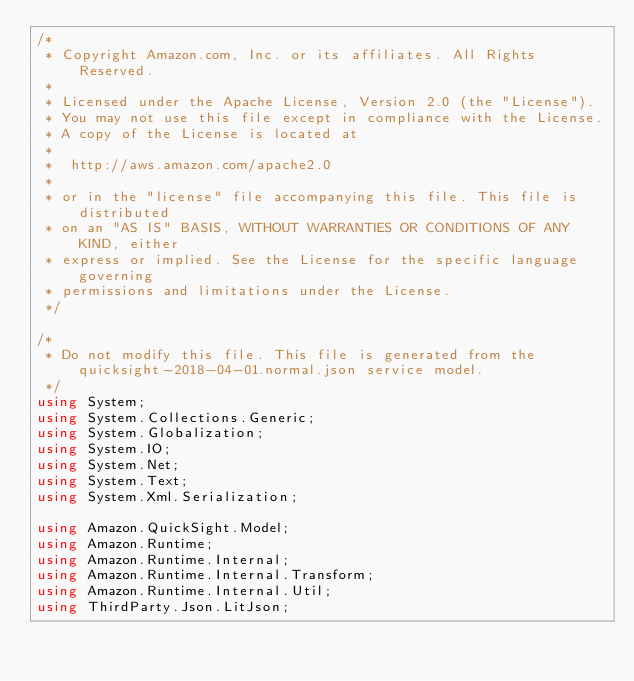Convert code to text. <code><loc_0><loc_0><loc_500><loc_500><_C#_>/*
 * Copyright Amazon.com, Inc. or its affiliates. All Rights Reserved.
 * 
 * Licensed under the Apache License, Version 2.0 (the "License").
 * You may not use this file except in compliance with the License.
 * A copy of the License is located at
 * 
 *  http://aws.amazon.com/apache2.0
 * 
 * or in the "license" file accompanying this file. This file is distributed
 * on an "AS IS" BASIS, WITHOUT WARRANTIES OR CONDITIONS OF ANY KIND, either
 * express or implied. See the License for the specific language governing
 * permissions and limitations under the License.
 */

/*
 * Do not modify this file. This file is generated from the quicksight-2018-04-01.normal.json service model.
 */
using System;
using System.Collections.Generic;
using System.Globalization;
using System.IO;
using System.Net;
using System.Text;
using System.Xml.Serialization;

using Amazon.QuickSight.Model;
using Amazon.Runtime;
using Amazon.Runtime.Internal;
using Amazon.Runtime.Internal.Transform;
using Amazon.Runtime.Internal.Util;
using ThirdParty.Json.LitJson;</code> 